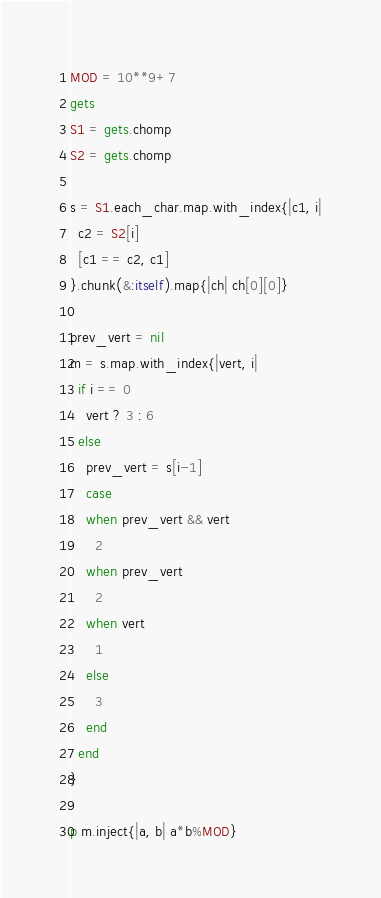<code> <loc_0><loc_0><loc_500><loc_500><_Ruby_>MOD = 10**9+7
gets
S1 = gets.chomp
S2 = gets.chomp

s = S1.each_char.map.with_index{|c1, i|
  c2 = S2[i]
  [c1 == c2, c1]
}.chunk(&:itself).map{|ch| ch[0][0]}

prev_vert = nil
m = s.map.with_index{|vert, i|
  if i == 0
    vert ? 3 : 6
  else
    prev_vert = s[i-1]
    case
    when prev_vert && vert
      2
    when prev_vert
      2
    when vert
      1
    else
      3
    end
  end
}

p m.inject{|a, b| a*b%MOD}
</code> 